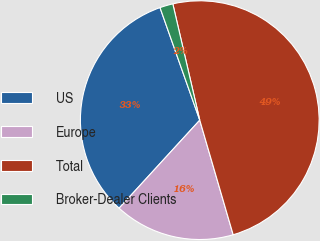<chart> <loc_0><loc_0><loc_500><loc_500><pie_chart><fcel>US<fcel>Europe<fcel>Total<fcel>Broker-Dealer Clients<nl><fcel>32.79%<fcel>16.32%<fcel>49.11%<fcel>1.78%<nl></chart> 